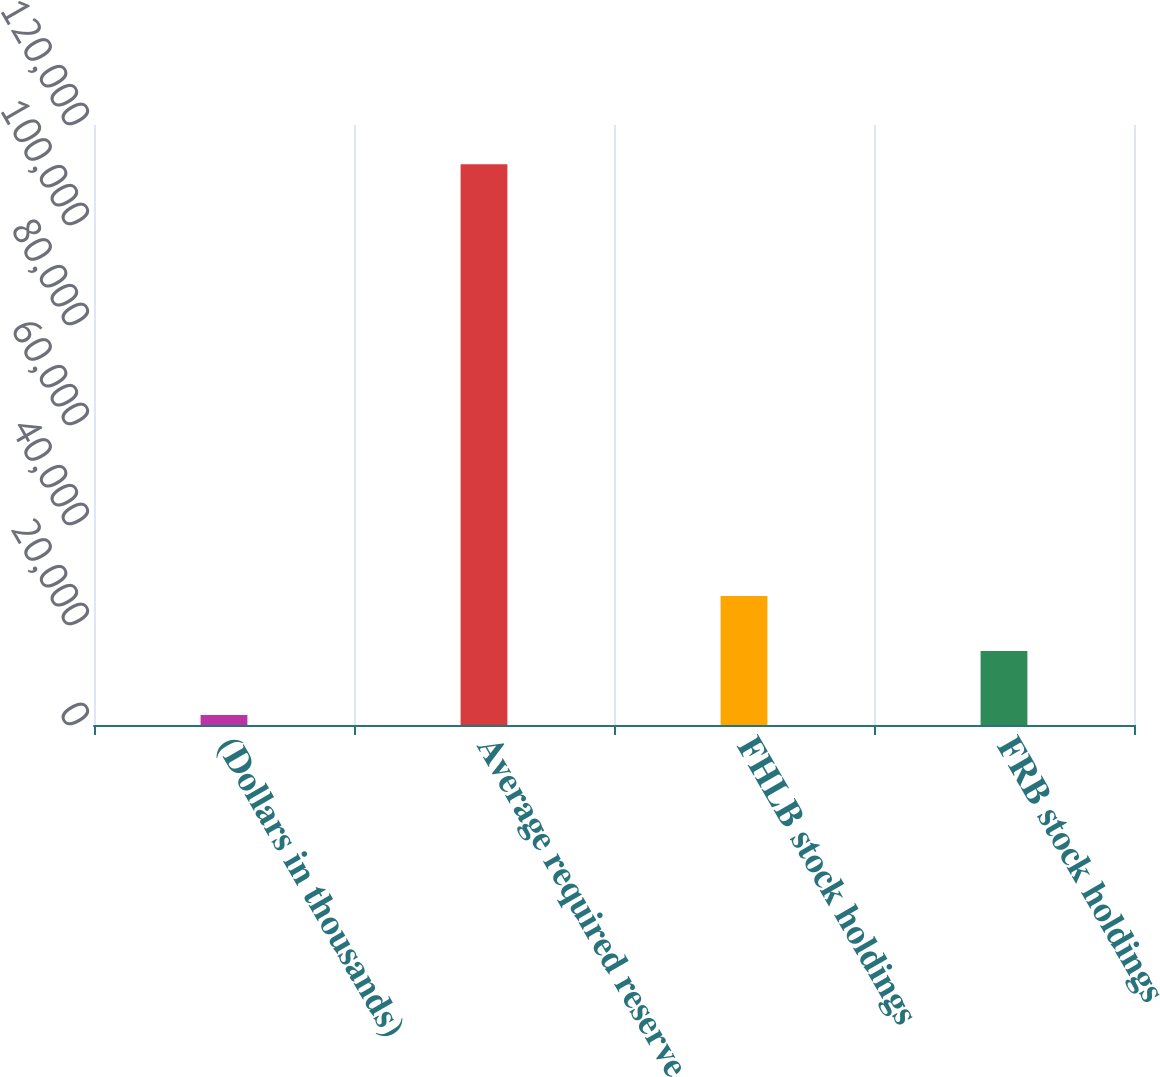<chart> <loc_0><loc_0><loc_500><loc_500><bar_chart><fcel>(Dollars in thousands)<fcel>Average required reserve<fcel>FHLB stock holdings<fcel>FRB stock holdings<nl><fcel>2012<fcel>112173<fcel>25822.1<fcel>14806<nl></chart> 